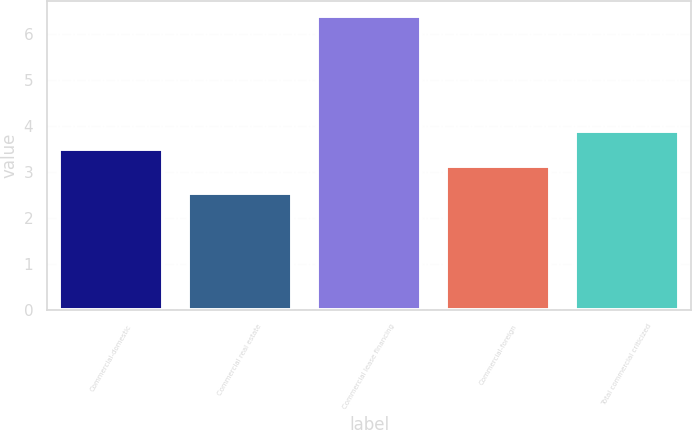Convert chart. <chart><loc_0><loc_0><loc_500><loc_500><bar_chart><fcel>Commercial-domestic<fcel>Commercial real estate<fcel>Commercial lease financing<fcel>Commercial-foreign<fcel>Total commercial criticized<nl><fcel>3.5<fcel>2.54<fcel>6.38<fcel>3.12<fcel>3.88<nl></chart> 